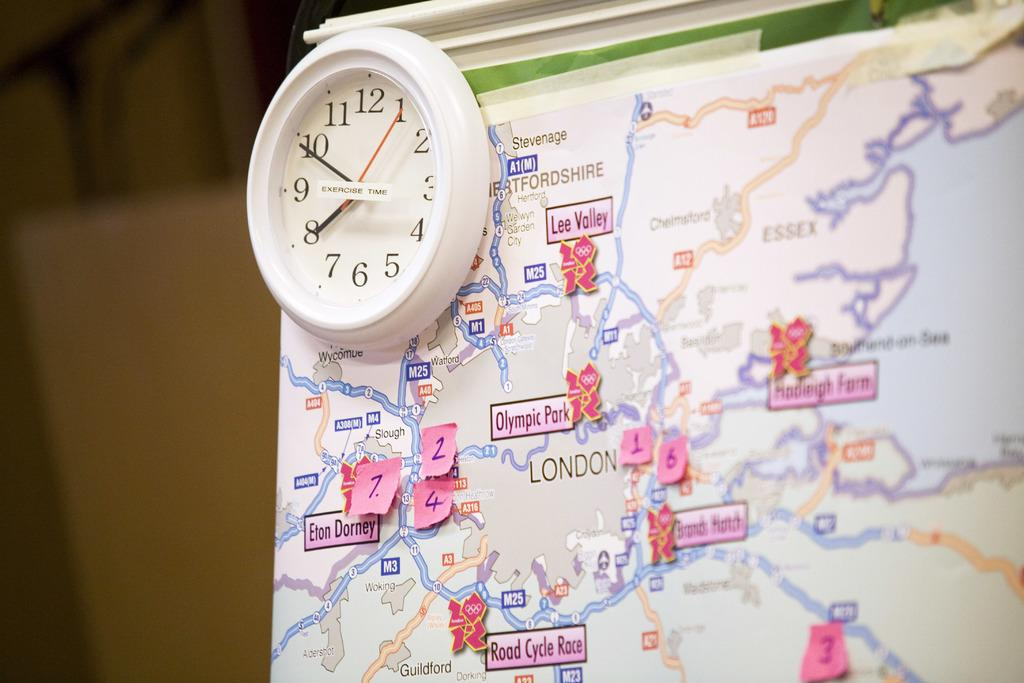<image>
Write a terse but informative summary of the picture. A map of the lower part of the UK on which London is prominent. 